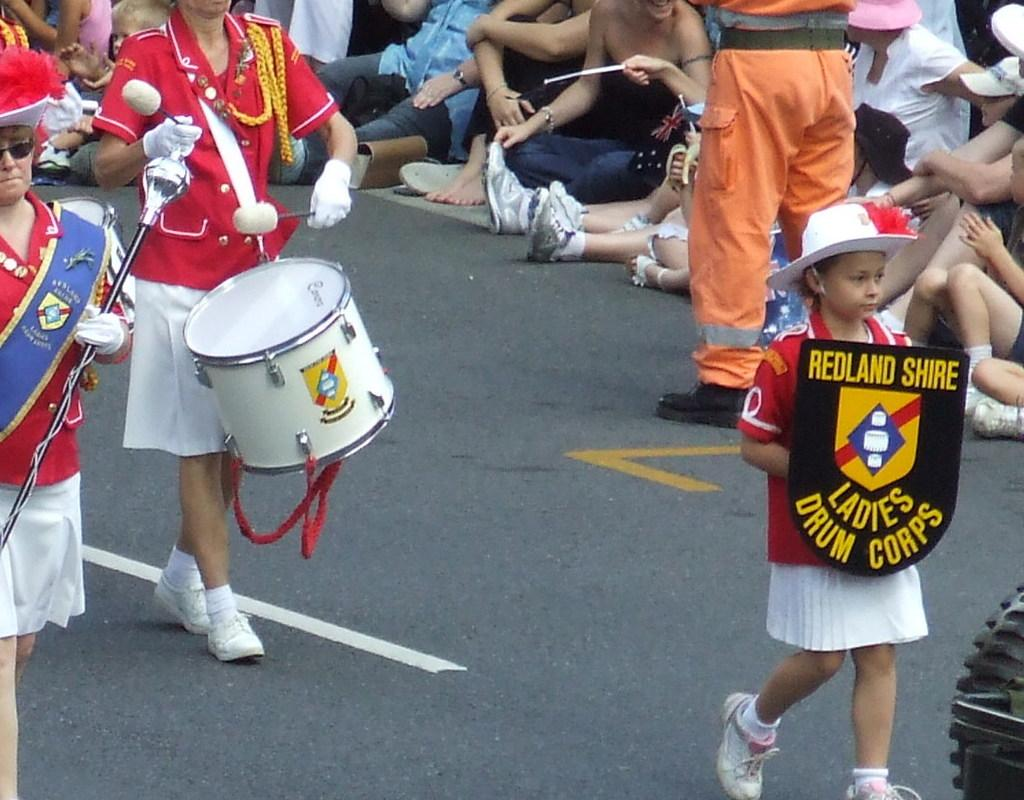<image>
Present a compact description of the photo's key features. the name Ladies is on a black shield 